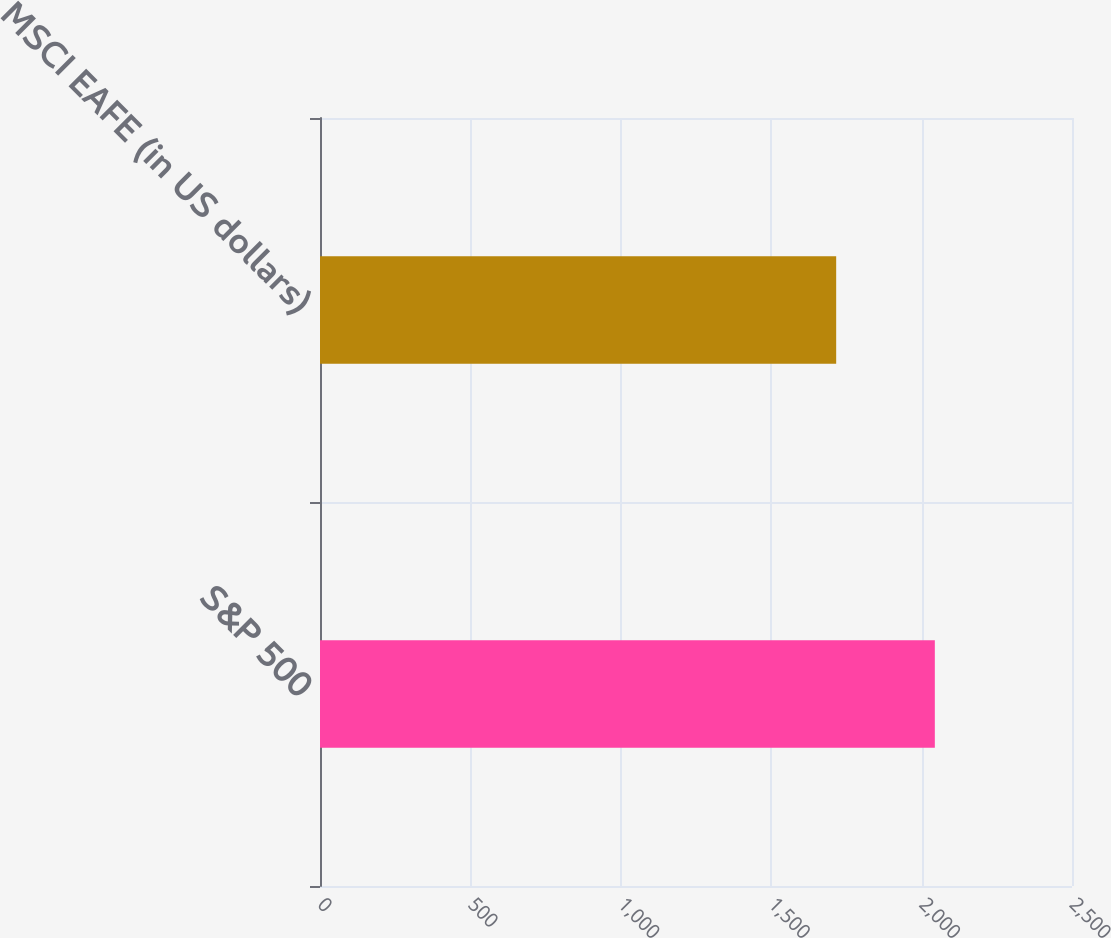<chart> <loc_0><loc_0><loc_500><loc_500><bar_chart><fcel>S&P 500<fcel>MSCI EAFE (in US dollars)<nl><fcel>2044<fcel>1716<nl></chart> 